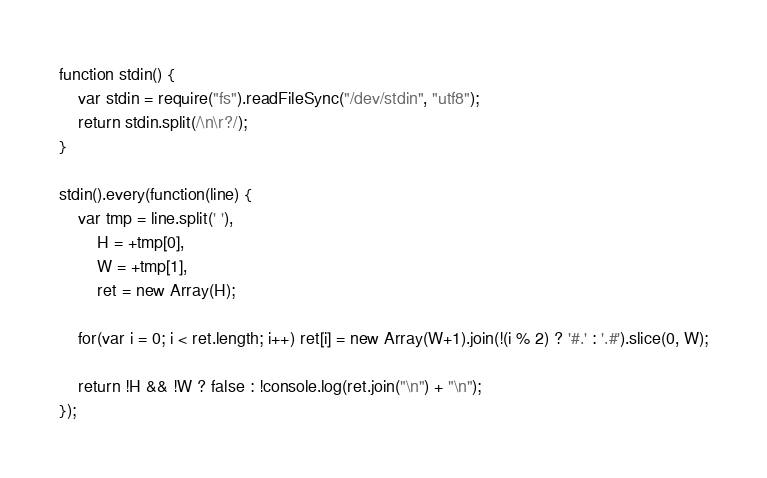<code> <loc_0><loc_0><loc_500><loc_500><_JavaScript_>function stdin() {
	var stdin = require("fs").readFileSync("/dev/stdin", "utf8");
	return stdin.split(/\n\r?/);
}

stdin().every(function(line) {
	var tmp = line.split(' '),
		H = +tmp[0],
		W = +tmp[1],
		ret = new Array(H);

	for(var i = 0; i < ret.length; i++) ret[i] = new Array(W+1).join(!(i % 2) ? '#.' : '.#').slice(0, W);

	return !H && !W ? false : !console.log(ret.join("\n") + "\n");
});</code> 